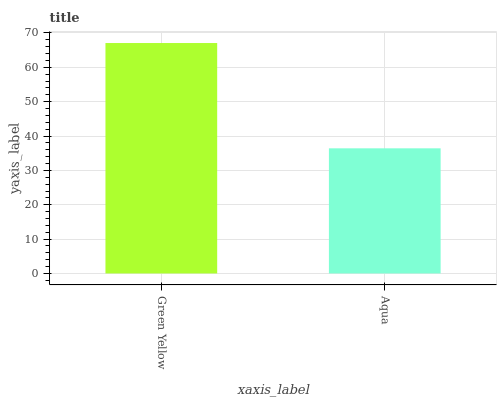Is Aqua the minimum?
Answer yes or no. Yes. Is Green Yellow the maximum?
Answer yes or no. Yes. Is Aqua the maximum?
Answer yes or no. No. Is Green Yellow greater than Aqua?
Answer yes or no. Yes. Is Aqua less than Green Yellow?
Answer yes or no. Yes. Is Aqua greater than Green Yellow?
Answer yes or no. No. Is Green Yellow less than Aqua?
Answer yes or no. No. Is Green Yellow the high median?
Answer yes or no. Yes. Is Aqua the low median?
Answer yes or no. Yes. Is Aqua the high median?
Answer yes or no. No. Is Green Yellow the low median?
Answer yes or no. No. 